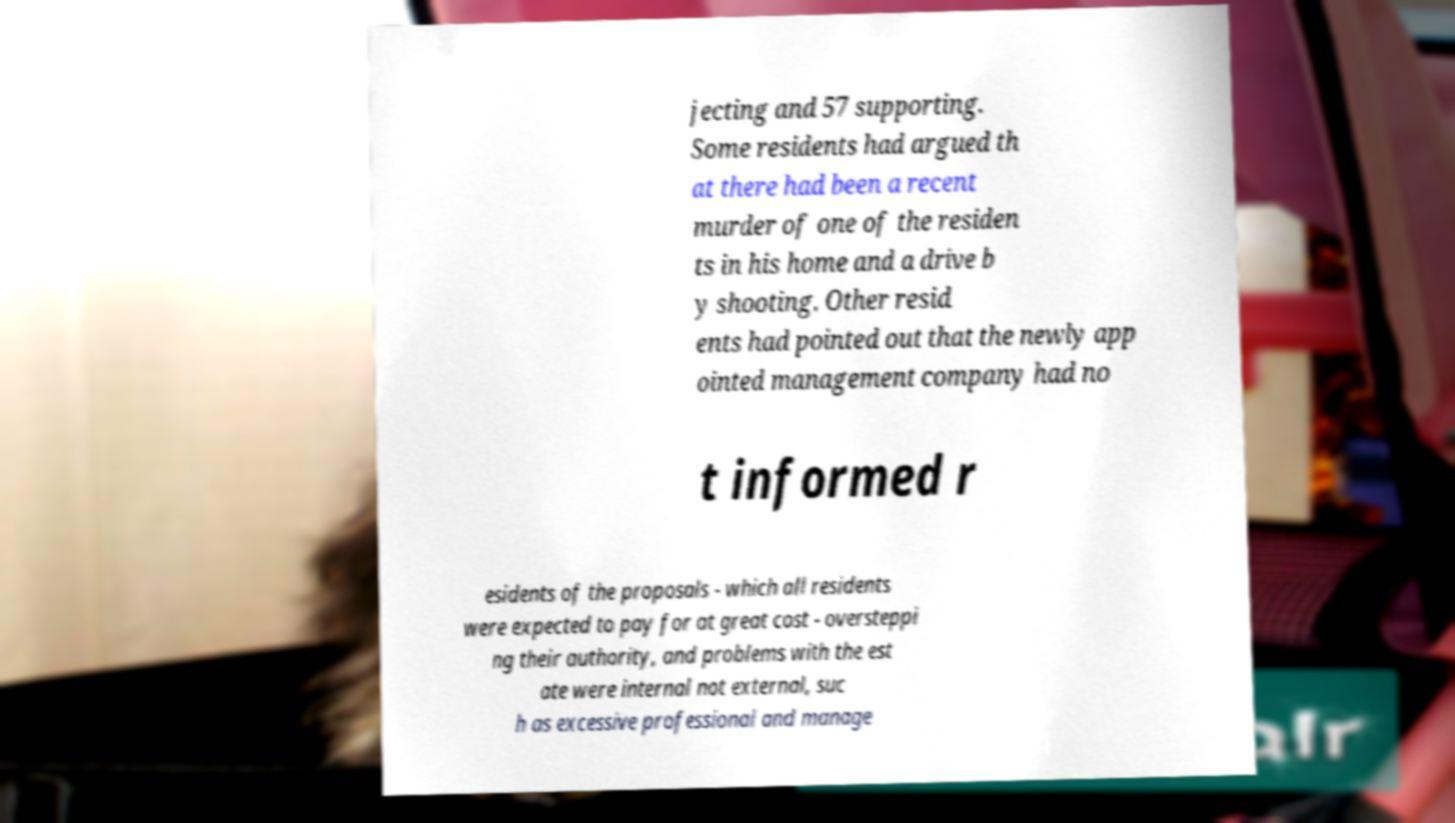There's text embedded in this image that I need extracted. Can you transcribe it verbatim? jecting and 57 supporting. Some residents had argued th at there had been a recent murder of one of the residen ts in his home and a drive b y shooting. Other resid ents had pointed out that the newly app ointed management company had no t informed r esidents of the proposals - which all residents were expected to pay for at great cost - oversteppi ng their authority, and problems with the est ate were internal not external, suc h as excessive professional and manage 